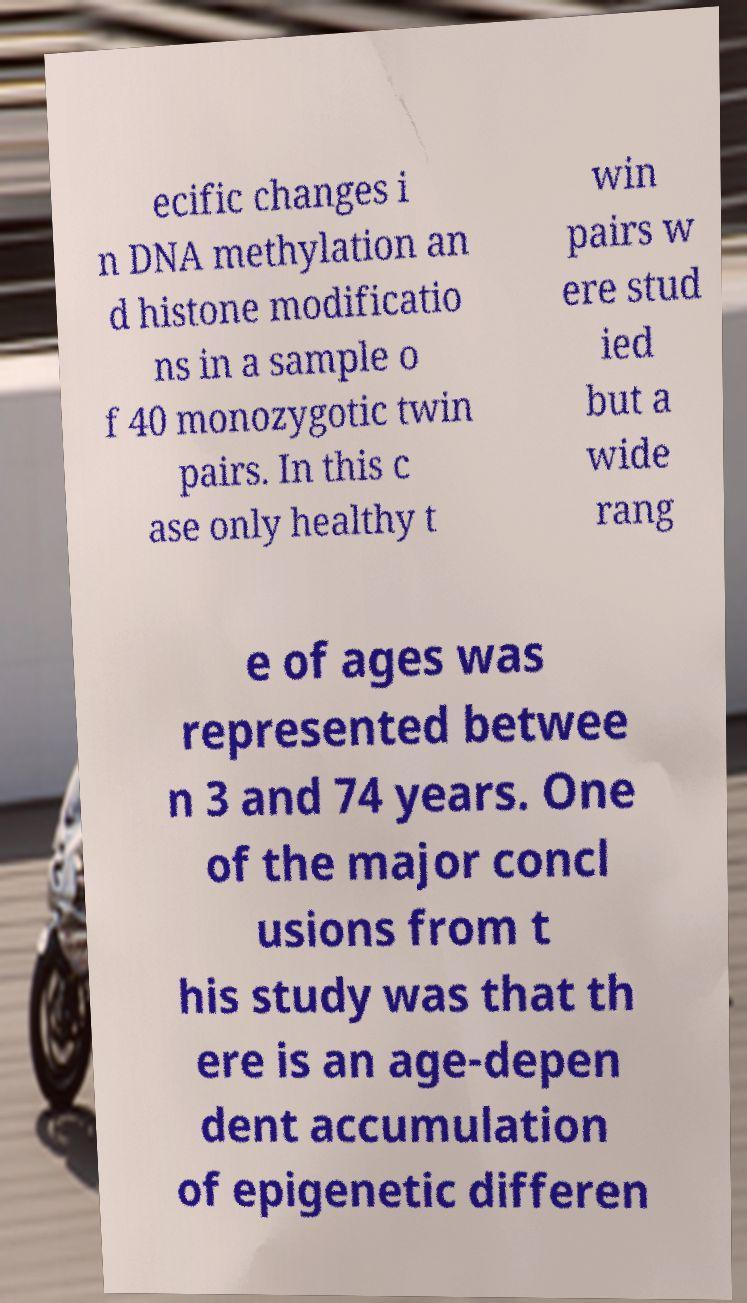For documentation purposes, I need the text within this image transcribed. Could you provide that? ecific changes i n DNA methylation an d histone modificatio ns in a sample o f 40 monozygotic twin pairs. In this c ase only healthy t win pairs w ere stud ied but a wide rang e of ages was represented betwee n 3 and 74 years. One of the major concl usions from t his study was that th ere is an age-depen dent accumulation of epigenetic differen 